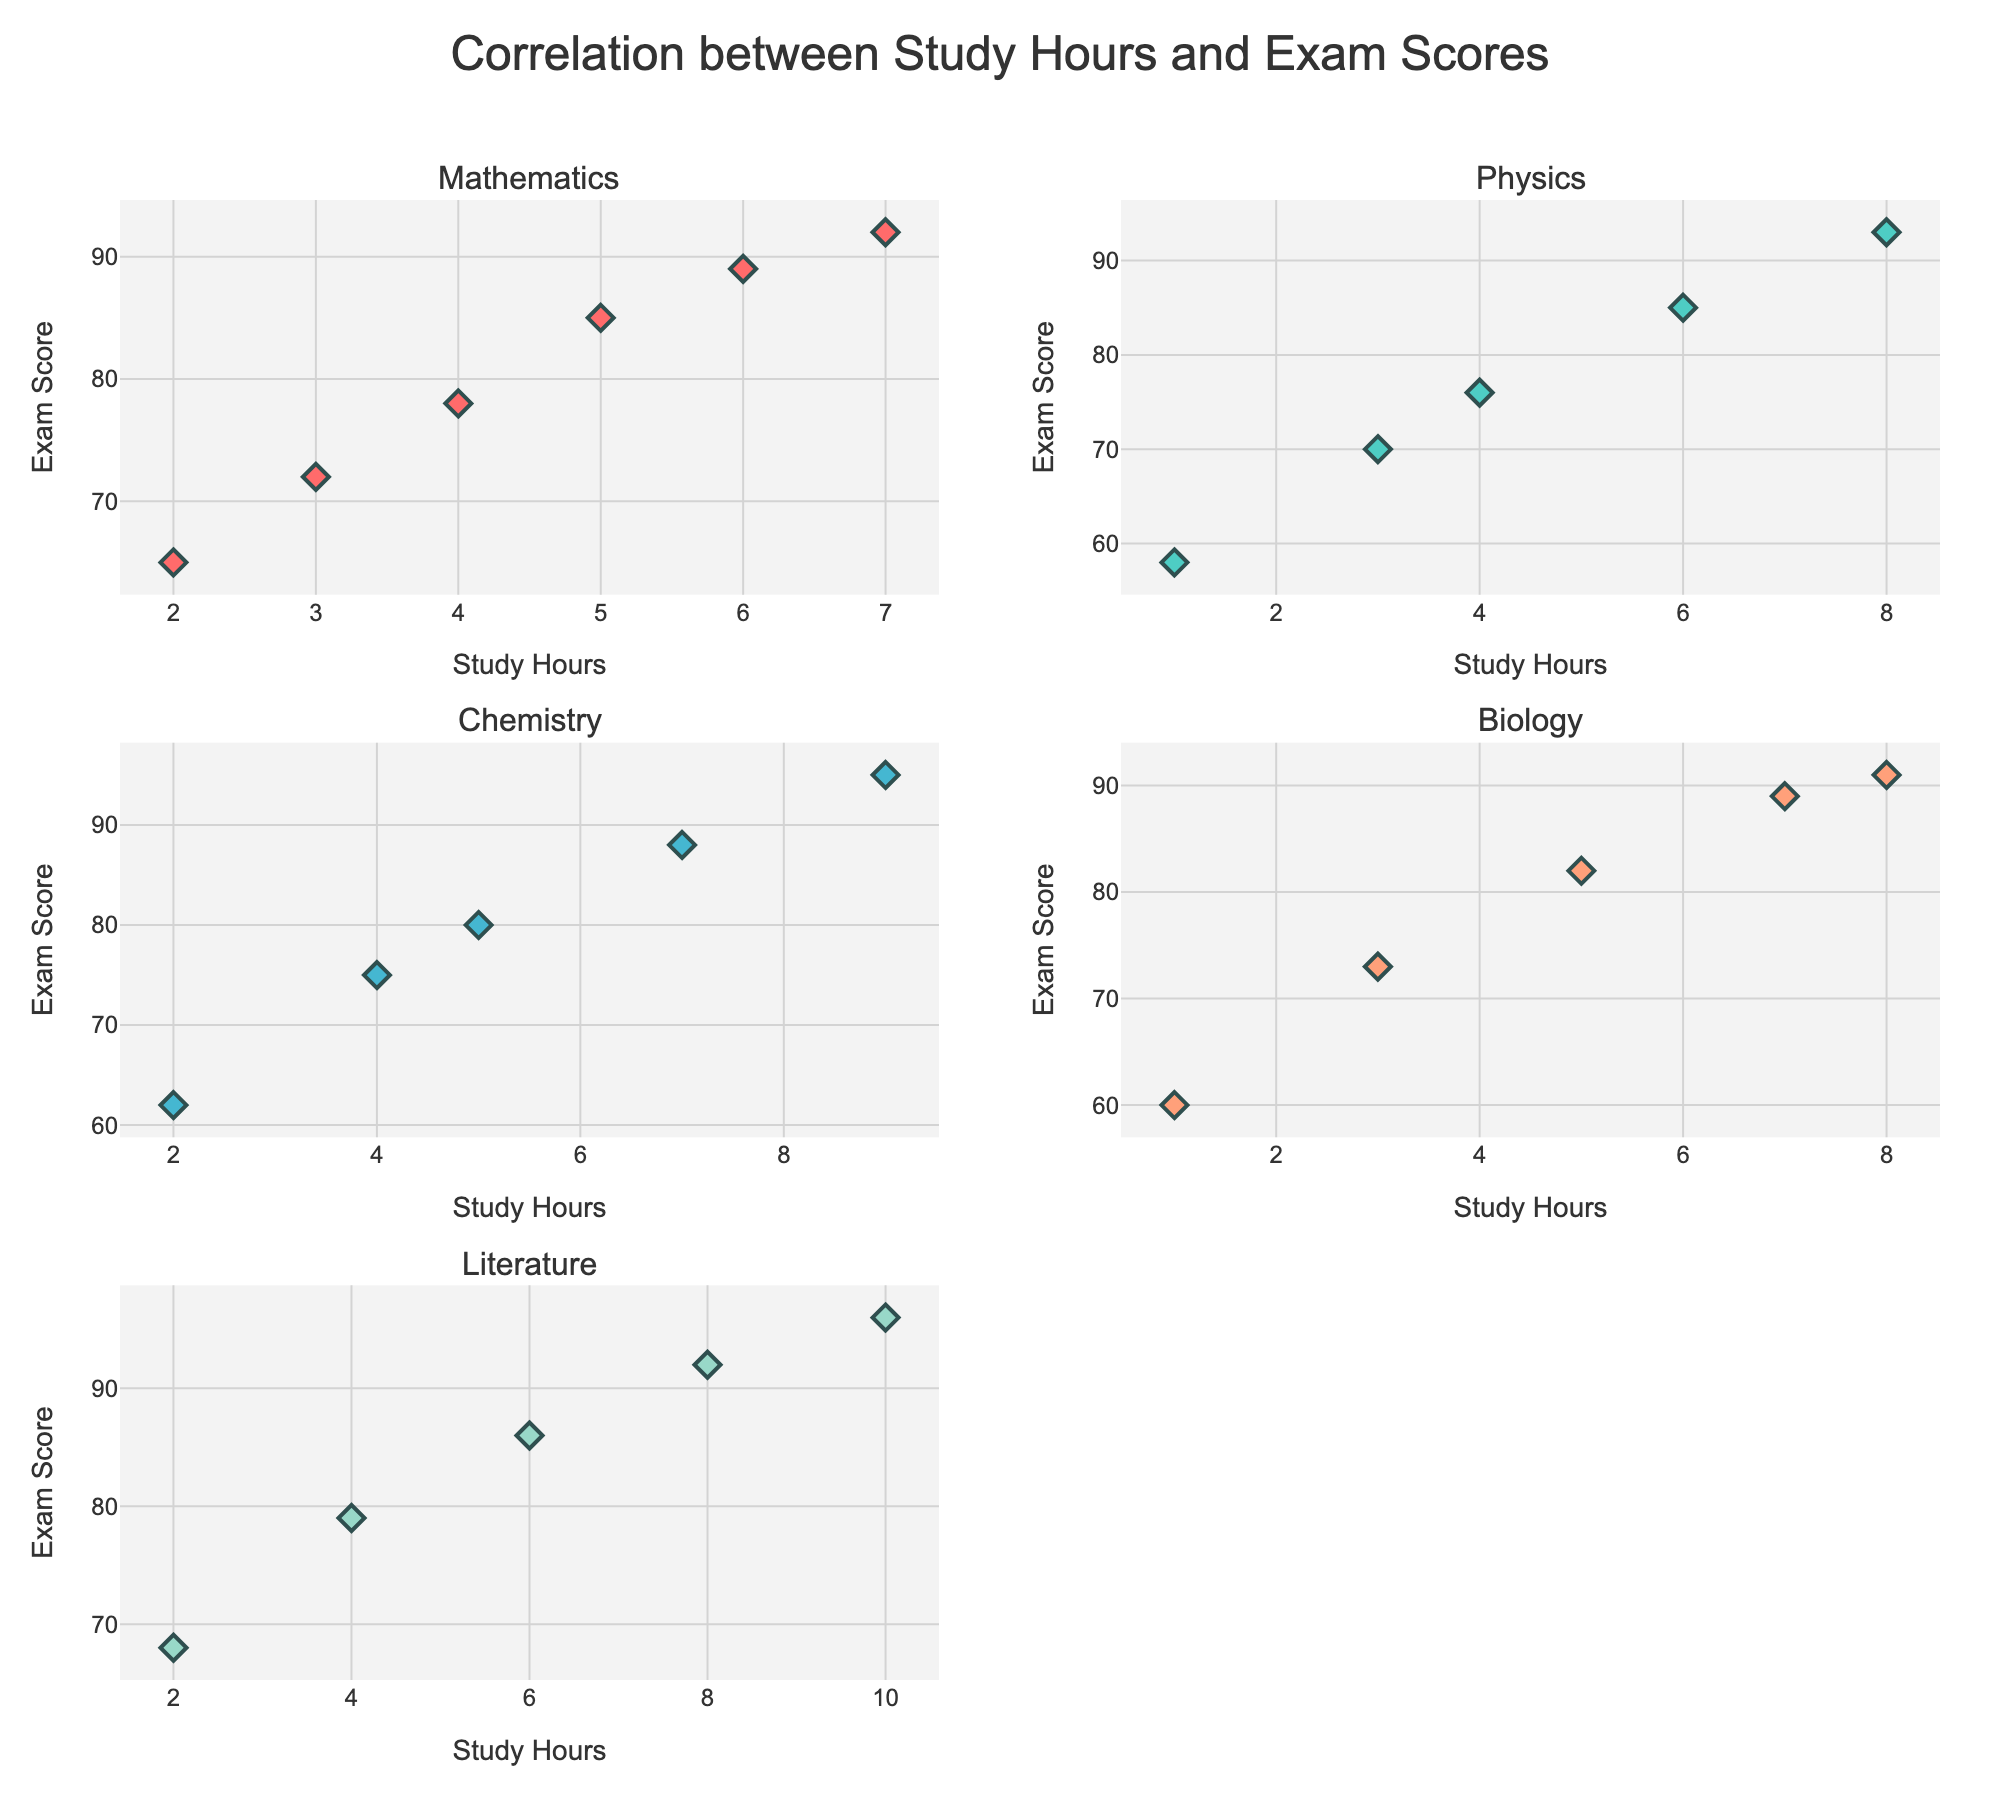What's the title of the figure? The title is located at the top center of the figure and clearly states the subject of the data visualization.
Answer: Correlation between Study Hours and Exam Scores How many subjects are represented in the figure? The subplot titles represent the different subjects. Counting these should give the number of subjects represented.
Answer: 5 Which subject has the highest exam score, and what is that score? Examine which subject plot contains the highest y-axis value. The Literature plot shows an exam score of 96.
Answer: Literature, 96 How does study time impact exam scores in Mathematics? Look at the trend of the points in the Mathematics subplot, which shows that as Study Hours increase, the Exam Score also increases, indicating a positive correlation.
Answer: Positively correlated What’s the difference between the highest and lowest exam scores in Physics? Identify the highest and lowest points in the Physics subplot and calculate the difference between their y-values. Highest is 93, lowest is 58, so the difference is 93 - 58.
Answer: 35 Which subject shows the strongest positive correlation between study hours and exam scores? Examine the scatter plots to see which one has the most linear and steep upward trend.
Answer: Literature In Biology, what is the exam score when study hours are equal to 5? Locate the point where the x-axis is 5 in the Biology subplot and check its corresponding y-axis value.
Answer: 82 Is there any subject where study hours do not show a clear correlation with exam scores? Check all the subplots to see if any do not display a clear trend line. All subjects show a positive correlation.
Answer: No What are the range of study hours for Chemistry? The range is the difference between the maximum and minimum values on the x-axis in the Chemistry subplot. The minimum is 2, and the maximum is 9.
Answer: 7 Which two subjects have the closest highest exam scores? Compare the highest y-values in all subplots. Chemistry and Literature both have high scores in the mid-90s; checking these, they both peak at 96.
Answer: Chemistry and Literature 